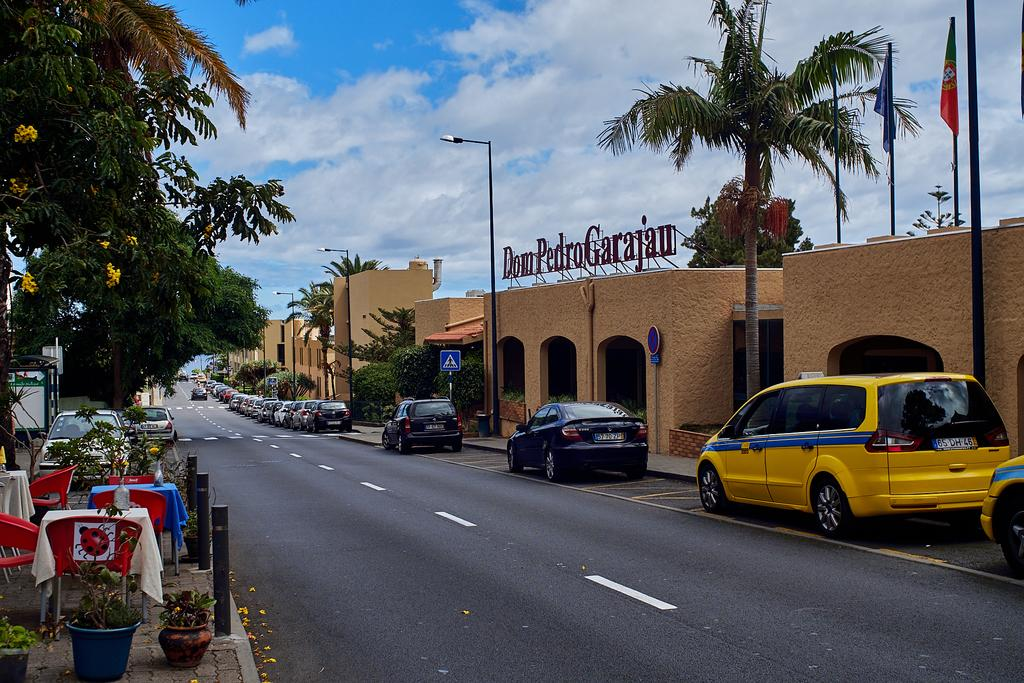<image>
Summarize the visual content of the image. Cars park along the street in front of Don Pedro Garajau. 